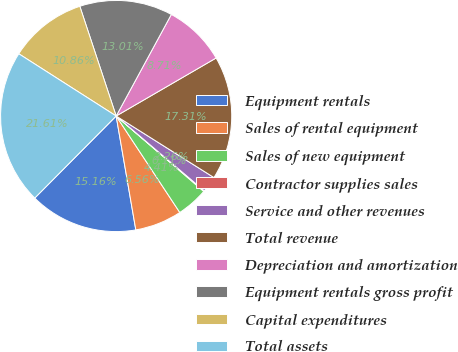Convert chart to OTSL. <chart><loc_0><loc_0><loc_500><loc_500><pie_chart><fcel>Equipment rentals<fcel>Sales of rental equipment<fcel>Sales of new equipment<fcel>Contractor supplies sales<fcel>Service and other revenues<fcel>Total revenue<fcel>Depreciation and amortization<fcel>Equipment rentals gross profit<fcel>Capital expenditures<fcel>Total assets<nl><fcel>15.16%<fcel>6.56%<fcel>4.41%<fcel>0.11%<fcel>2.26%<fcel>17.31%<fcel>8.71%<fcel>13.01%<fcel>10.86%<fcel>21.61%<nl></chart> 